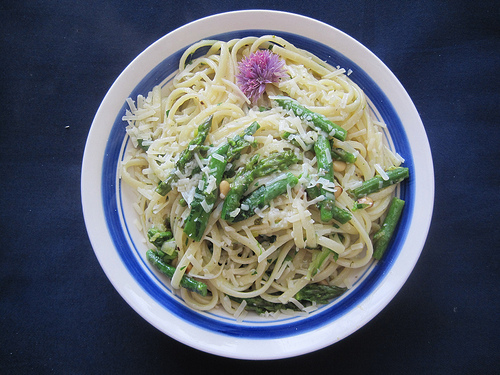<image>
Is the food on the table? Yes. Looking at the image, I can see the food is positioned on top of the table, with the table providing support. Is there a flower on the pine nut? No. The flower is not positioned on the pine nut. They may be near each other, but the flower is not supported by or resting on top of the pine nut. Is the plate under the food? Yes. The plate is positioned underneath the food, with the food above it in the vertical space. Is the flower above the plate? Yes. The flower is positioned above the plate in the vertical space, higher up in the scene. 